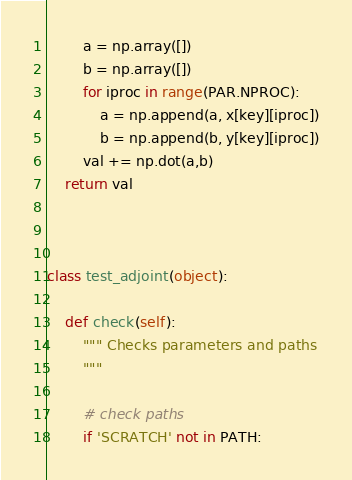Convert code to text. <code><loc_0><loc_0><loc_500><loc_500><_Python_>        a = np.array([])
        b = np.array([])
        for iproc in range(PAR.NPROC):
            a = np.append(a, x[key][iproc])
            b = np.append(b, y[key][iproc])
        val += np.dot(a,b)
    return val



class test_adjoint(object):

    def check(self):
        """ Checks parameters and paths
        """

        # check paths
        if 'SCRATCH' not in PATH:</code> 